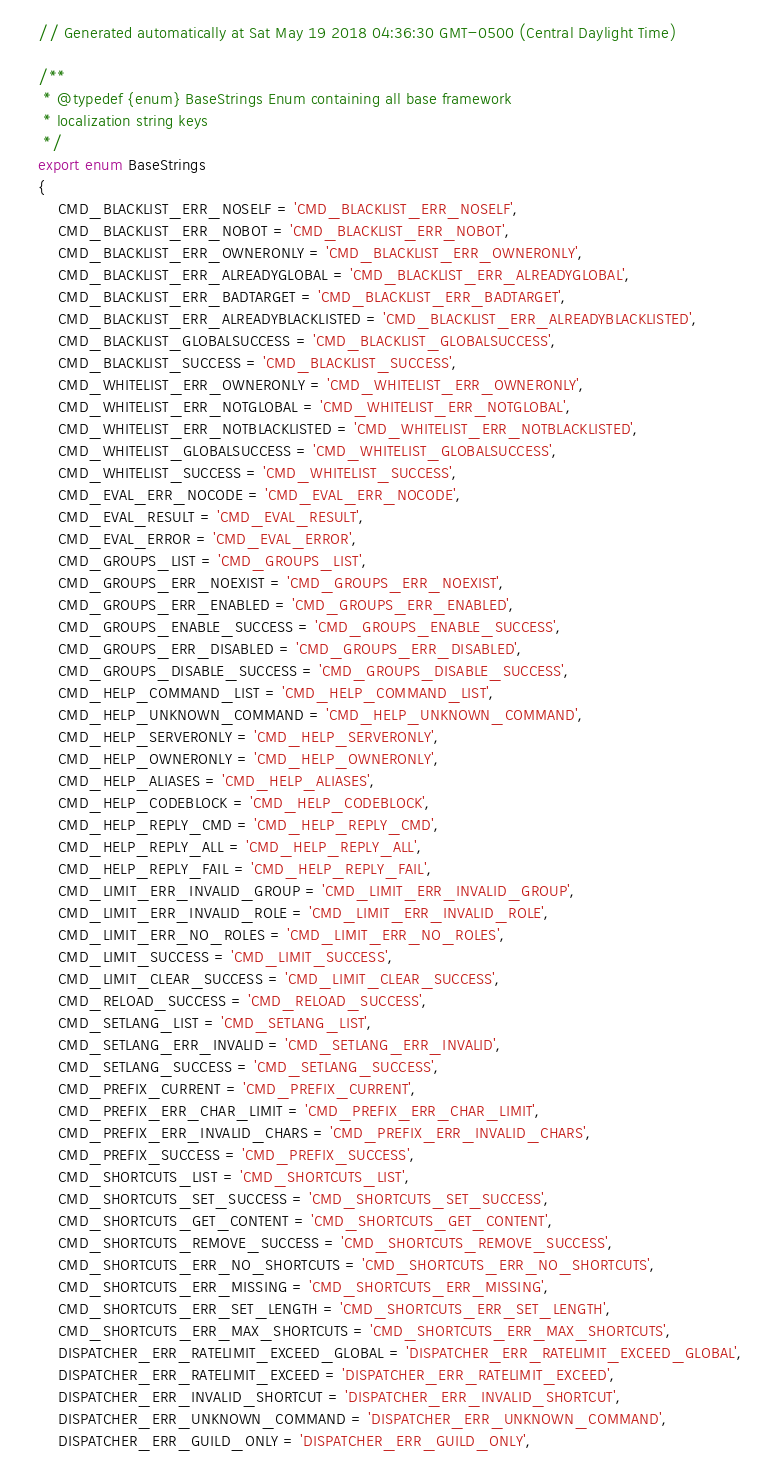<code> <loc_0><loc_0><loc_500><loc_500><_TypeScript_>// Generated automatically at Sat May 19 2018 04:36:30 GMT-0500 (Central Daylight Time)

/**
 * @typedef {enum} BaseStrings Enum containing all base framework
 * localization string keys
 */
export enum BaseStrings
{
	CMD_BLACKLIST_ERR_NOSELF = 'CMD_BLACKLIST_ERR_NOSELF',
	CMD_BLACKLIST_ERR_NOBOT = 'CMD_BLACKLIST_ERR_NOBOT',
	CMD_BLACKLIST_ERR_OWNERONLY = 'CMD_BLACKLIST_ERR_OWNERONLY',
	CMD_BLACKLIST_ERR_ALREADYGLOBAL = 'CMD_BLACKLIST_ERR_ALREADYGLOBAL',
	CMD_BLACKLIST_ERR_BADTARGET = 'CMD_BLACKLIST_ERR_BADTARGET',
	CMD_BLACKLIST_ERR_ALREADYBLACKLISTED = 'CMD_BLACKLIST_ERR_ALREADYBLACKLISTED',
	CMD_BLACKLIST_GLOBALSUCCESS = 'CMD_BLACKLIST_GLOBALSUCCESS',
	CMD_BLACKLIST_SUCCESS = 'CMD_BLACKLIST_SUCCESS',
	CMD_WHITELIST_ERR_OWNERONLY = 'CMD_WHITELIST_ERR_OWNERONLY',
	CMD_WHITELIST_ERR_NOTGLOBAL = 'CMD_WHITELIST_ERR_NOTGLOBAL',
	CMD_WHITELIST_ERR_NOTBLACKLISTED = 'CMD_WHITELIST_ERR_NOTBLACKLISTED',
	CMD_WHITELIST_GLOBALSUCCESS = 'CMD_WHITELIST_GLOBALSUCCESS',
	CMD_WHITELIST_SUCCESS = 'CMD_WHITELIST_SUCCESS',
	CMD_EVAL_ERR_NOCODE = 'CMD_EVAL_ERR_NOCODE',
	CMD_EVAL_RESULT = 'CMD_EVAL_RESULT',
	CMD_EVAL_ERROR = 'CMD_EVAL_ERROR',
	CMD_GROUPS_LIST = 'CMD_GROUPS_LIST',
	CMD_GROUPS_ERR_NOEXIST = 'CMD_GROUPS_ERR_NOEXIST',
	CMD_GROUPS_ERR_ENABLED = 'CMD_GROUPS_ERR_ENABLED',
	CMD_GROUPS_ENABLE_SUCCESS = 'CMD_GROUPS_ENABLE_SUCCESS',
	CMD_GROUPS_ERR_DISABLED = 'CMD_GROUPS_ERR_DISABLED',
	CMD_GROUPS_DISABLE_SUCCESS = 'CMD_GROUPS_DISABLE_SUCCESS',
	CMD_HELP_COMMAND_LIST = 'CMD_HELP_COMMAND_LIST',
	CMD_HELP_UNKNOWN_COMMAND = 'CMD_HELP_UNKNOWN_COMMAND',
	CMD_HELP_SERVERONLY = 'CMD_HELP_SERVERONLY',
	CMD_HELP_OWNERONLY = 'CMD_HELP_OWNERONLY',
	CMD_HELP_ALIASES = 'CMD_HELP_ALIASES',
	CMD_HELP_CODEBLOCK = 'CMD_HELP_CODEBLOCK',
	CMD_HELP_REPLY_CMD = 'CMD_HELP_REPLY_CMD',
	CMD_HELP_REPLY_ALL = 'CMD_HELP_REPLY_ALL',
	CMD_HELP_REPLY_FAIL = 'CMD_HELP_REPLY_FAIL',
	CMD_LIMIT_ERR_INVALID_GROUP = 'CMD_LIMIT_ERR_INVALID_GROUP',
	CMD_LIMIT_ERR_INVALID_ROLE = 'CMD_LIMIT_ERR_INVALID_ROLE',
	CMD_LIMIT_ERR_NO_ROLES = 'CMD_LIMIT_ERR_NO_ROLES',
	CMD_LIMIT_SUCCESS = 'CMD_LIMIT_SUCCESS',
	CMD_LIMIT_CLEAR_SUCCESS = 'CMD_LIMIT_CLEAR_SUCCESS',
	CMD_RELOAD_SUCCESS = 'CMD_RELOAD_SUCCESS',
	CMD_SETLANG_LIST = 'CMD_SETLANG_LIST',
	CMD_SETLANG_ERR_INVALID = 'CMD_SETLANG_ERR_INVALID',
	CMD_SETLANG_SUCCESS = 'CMD_SETLANG_SUCCESS',
	CMD_PREFIX_CURRENT = 'CMD_PREFIX_CURRENT',
	CMD_PREFIX_ERR_CHAR_LIMIT = 'CMD_PREFIX_ERR_CHAR_LIMIT',
	CMD_PREFIX_ERR_INVALID_CHARS = 'CMD_PREFIX_ERR_INVALID_CHARS',
	CMD_PREFIX_SUCCESS = 'CMD_PREFIX_SUCCESS',
	CMD_SHORTCUTS_LIST = 'CMD_SHORTCUTS_LIST',
	CMD_SHORTCUTS_SET_SUCCESS = 'CMD_SHORTCUTS_SET_SUCCESS',
	CMD_SHORTCUTS_GET_CONTENT = 'CMD_SHORTCUTS_GET_CONTENT',
	CMD_SHORTCUTS_REMOVE_SUCCESS = 'CMD_SHORTCUTS_REMOVE_SUCCESS',
	CMD_SHORTCUTS_ERR_NO_SHORTCUTS = 'CMD_SHORTCUTS_ERR_NO_SHORTCUTS',
	CMD_SHORTCUTS_ERR_MISSING = 'CMD_SHORTCUTS_ERR_MISSING',
	CMD_SHORTCUTS_ERR_SET_LENGTH = 'CMD_SHORTCUTS_ERR_SET_LENGTH',
	CMD_SHORTCUTS_ERR_MAX_SHORTCUTS = 'CMD_SHORTCUTS_ERR_MAX_SHORTCUTS',
	DISPATCHER_ERR_RATELIMIT_EXCEED_GLOBAL = 'DISPATCHER_ERR_RATELIMIT_EXCEED_GLOBAL',
	DISPATCHER_ERR_RATELIMIT_EXCEED = 'DISPATCHER_ERR_RATELIMIT_EXCEED',
	DISPATCHER_ERR_INVALID_SHORTCUT = 'DISPATCHER_ERR_INVALID_SHORTCUT',
	DISPATCHER_ERR_UNKNOWN_COMMAND = 'DISPATCHER_ERR_UNKNOWN_COMMAND',
	DISPATCHER_ERR_GUILD_ONLY = 'DISPATCHER_ERR_GUILD_ONLY',</code> 